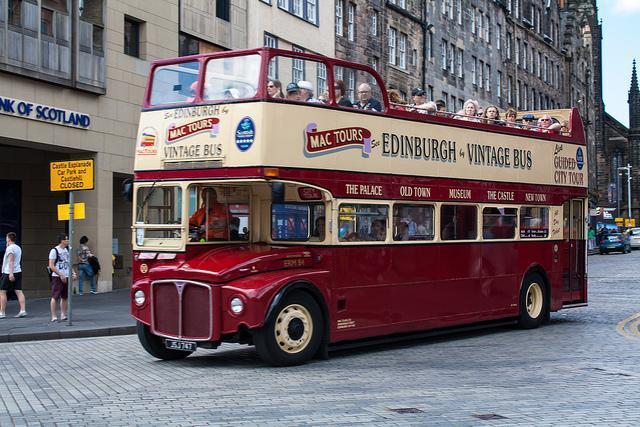How many slices of pizza are there?
Give a very brief answer. 0. 